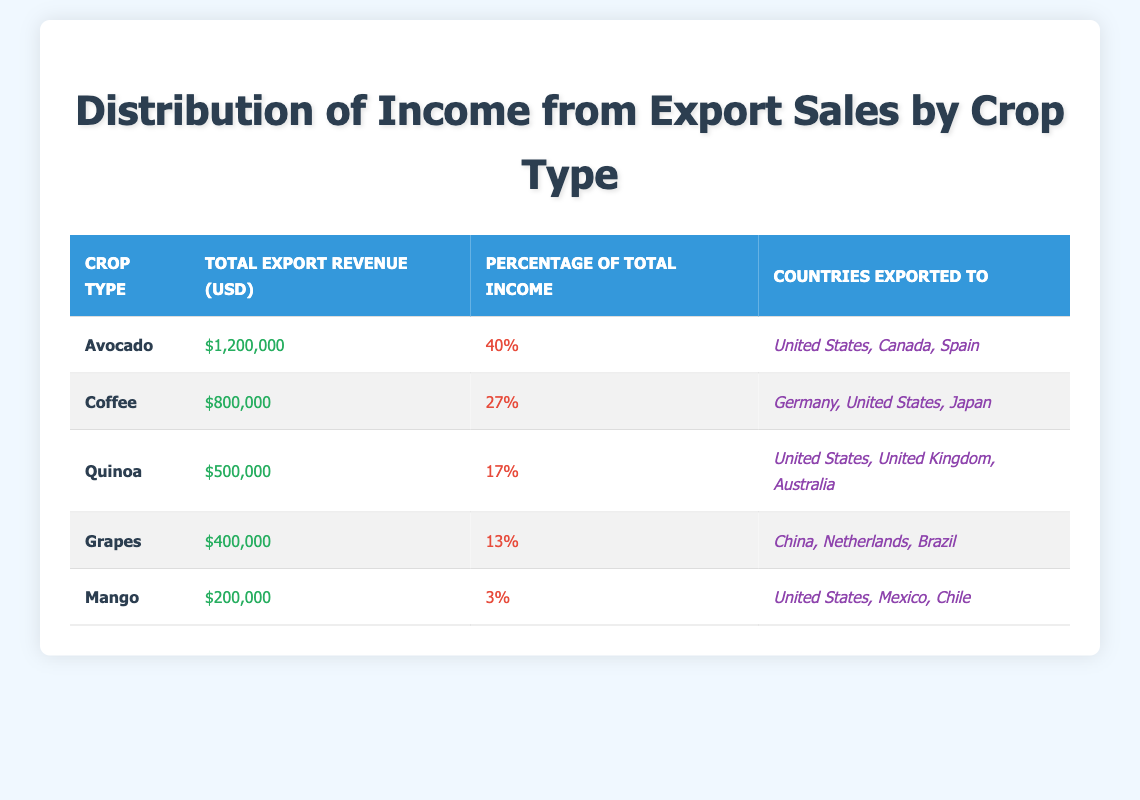What is the total export revenue from Avocado sales? The table shows that the total export revenue for Avocado is $1,200,000, as mentioned in the relevant row.
Answer: 1,200,000 Which crop type has the highest percentage of total income? According to the table, Avocado has the highest percentage of total income at 40%, compared to Coffee at 27%, Quinoa at 17%, Grapes at 13%, and Mango at 3%.
Answer: Avocado Is the total export revenue for Coffee greater than that for Grapes? The table states that Coffee has a total export revenue of $800,000 while Grapes have $400,000. Since $800,000 is greater than $400,000, the answer is yes.
Answer: Yes How much of the total income does Mango contribute? From the table, Mango contributes only 3% of the total income, which is the lowest among all crop types listed (compared to Avocado, Coffee, Quinoa, and Grapes).
Answer: 3% What is the combined total export revenue for Quinoa and Grapes? The total export revenue for Quinoa is $500,000 and for Grapes, it is $400,000. Adding both figures together gives $500,000 + $400,000 = $900,000.
Answer: 900,000 Are there more countries exported to for Avocado than for Mango? The table lists three countries for Avocado (United States, Canada, Spain) and three for Mango (United States, Mexico, Chile). Since both have the same number of countries, the answer is no.
Answer: No What percentage of total income comes from Coffee and Quinoa combined? Coffee contributes 27% and Quinoa contributes 17%. Adding these percentages gives 27% + 17% = 44%. Thus, Coffee and Quinoa together represent 44% of total income.
Answer: 44% Which crop type earns the lowest total export revenue? The table shows that Mango, with a total export revenue of $200,000, earns the least compared to all other crop types listed.
Answer: Mango 